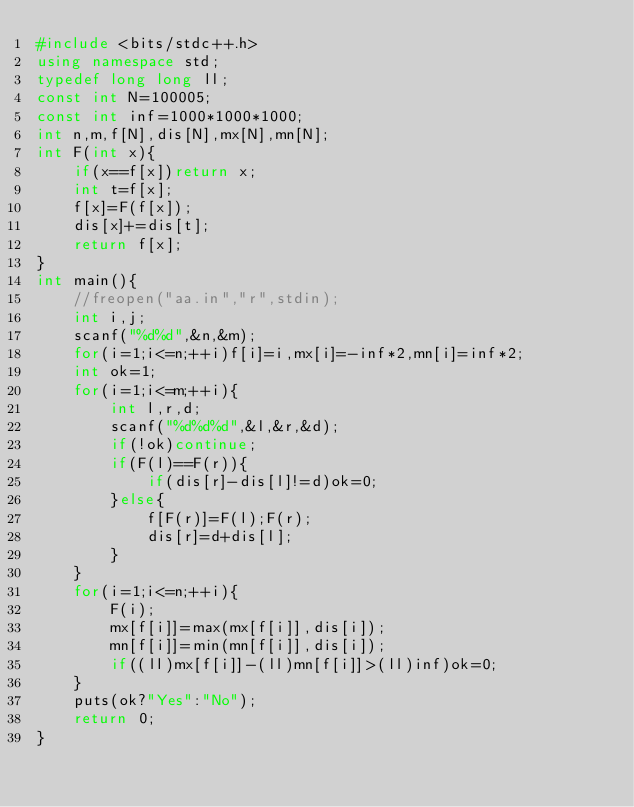<code> <loc_0><loc_0><loc_500><loc_500><_C++_>#include <bits/stdc++.h>
using namespace std;
typedef long long ll;
const int N=100005;
const int inf=1000*1000*1000;
int n,m,f[N],dis[N],mx[N],mn[N];
int F(int x){
	if(x==f[x])return x;
	int t=f[x];
	f[x]=F(f[x]);
	dis[x]+=dis[t];
	return f[x];
}
int main(){
	//freopen("aa.in","r",stdin);
	int i,j;
	scanf("%d%d",&n,&m);
	for(i=1;i<=n;++i)f[i]=i,mx[i]=-inf*2,mn[i]=inf*2;
	int ok=1;
	for(i=1;i<=m;++i){
		int l,r,d;
		scanf("%d%d%d",&l,&r,&d);
		if(!ok)continue;
		if(F(l)==F(r)){
			if(dis[r]-dis[l]!=d)ok=0;
		}else{
			f[F(r)]=F(l);F(r);
			dis[r]=d+dis[l];
		}
	}
	for(i=1;i<=n;++i){
		F(i);
		mx[f[i]]=max(mx[f[i]],dis[i]);
		mn[f[i]]=min(mn[f[i]],dis[i]);
		if((ll)mx[f[i]]-(ll)mn[f[i]]>(ll)inf)ok=0;
	}
	puts(ok?"Yes":"No");
	return 0;
}</code> 